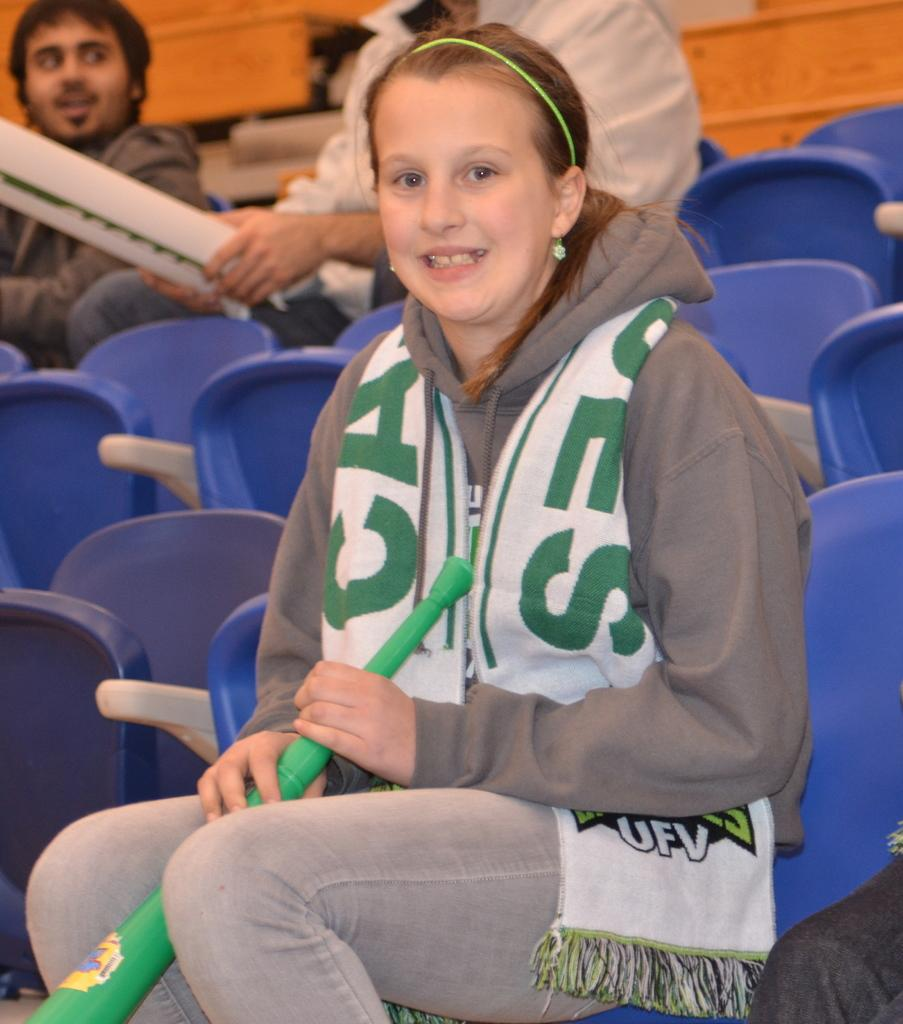<image>
Render a clear and concise summary of the photo. A girl wearing a white and green UFV scarf is seating on a blue plastic chair. 